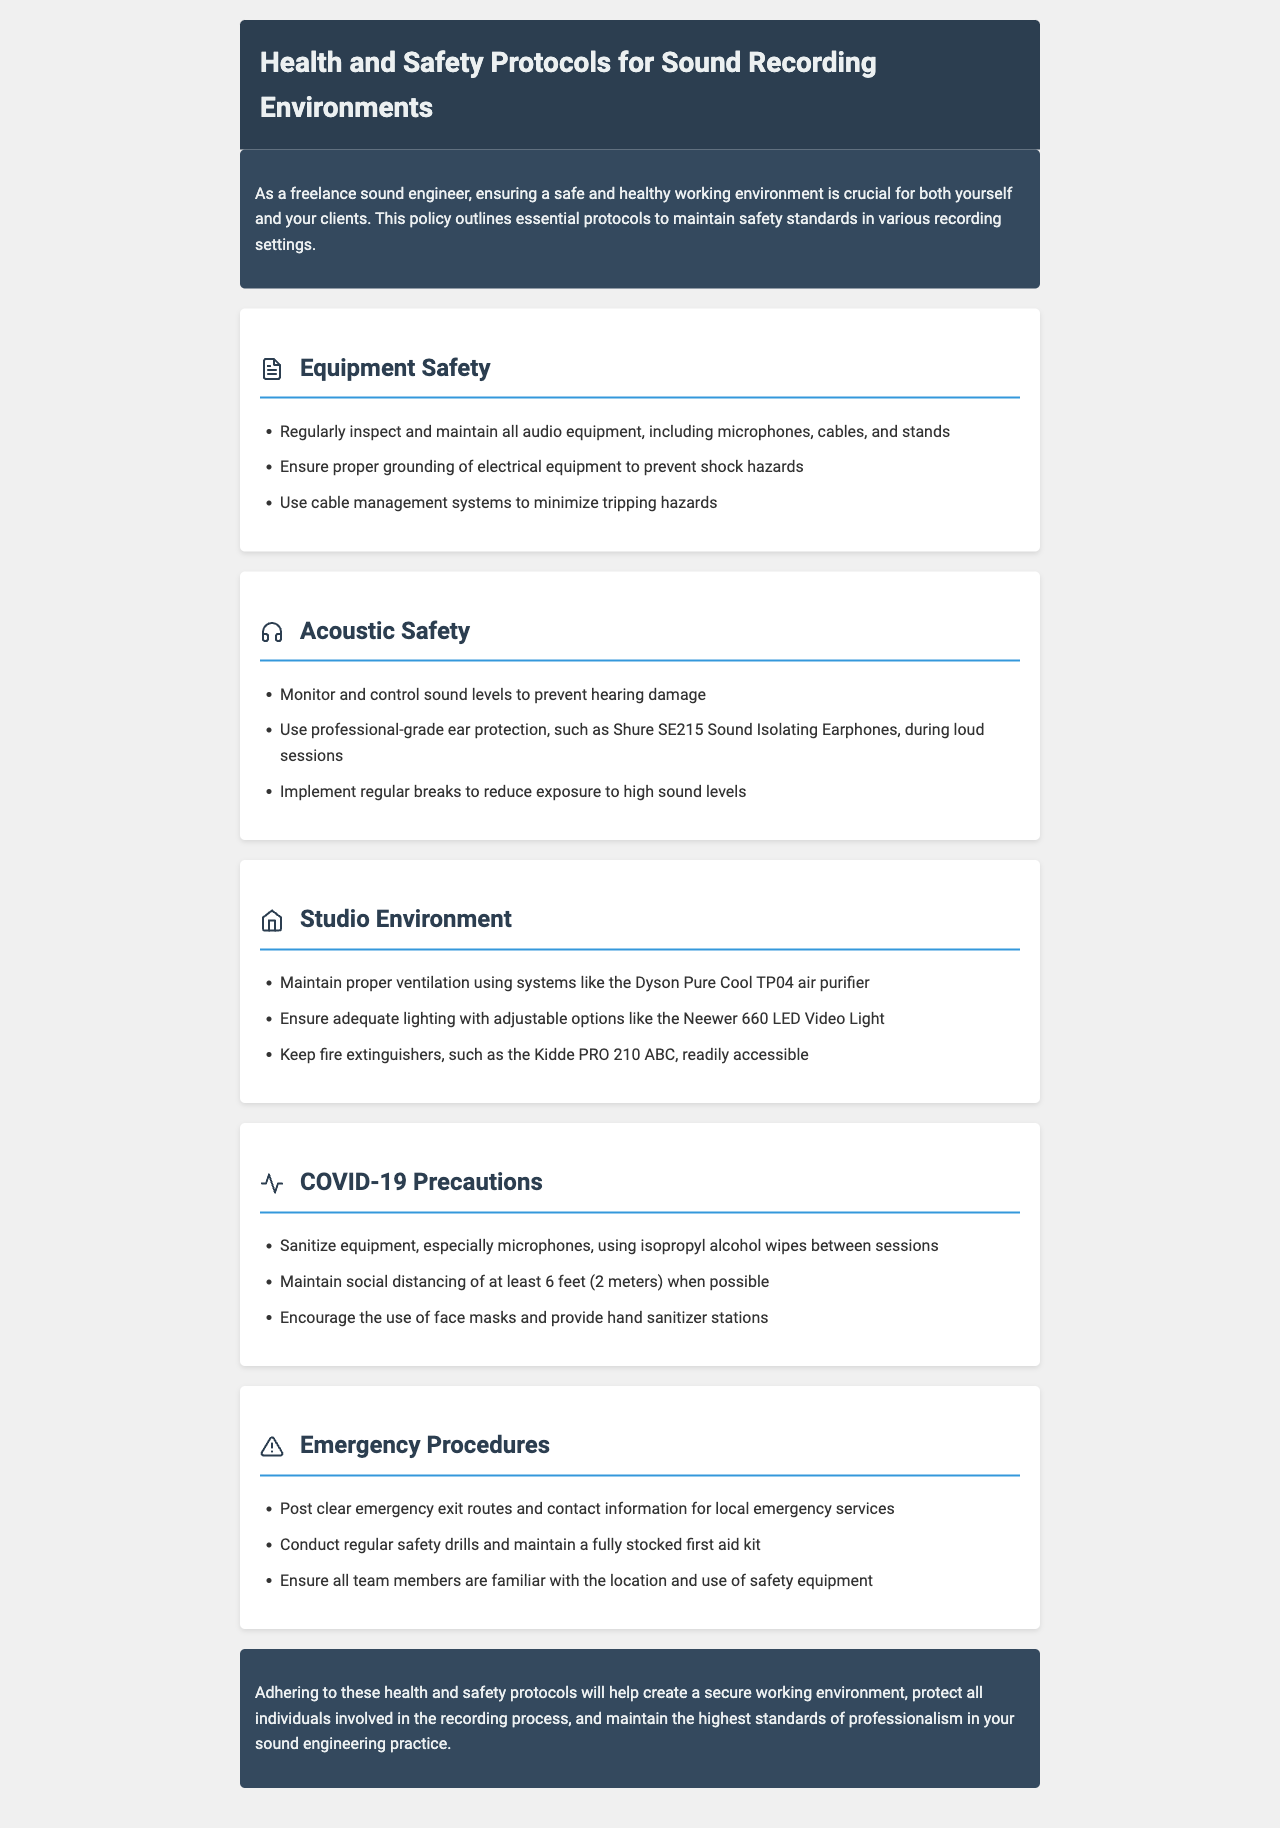What is the title of the document? The title is mentioned in the header section of the document, stating the purpose of the content.
Answer: Health and Safety Protocols for Sound Recording Environments What is the first section of the document? The first section outlines equipment safety, focusing on maintaining audio equipment and preventing hazards.
Answer: Equipment Safety What type of ear protection is recommended? The document specifies a professional-grade ear protection to use during loud sessions, providing specific product details.
Answer: Shure SE215 Sound Isolating Earphones What should be used to ensure adequate lighting? This document suggests specific lighting equipment that should be utilized to maintain a suitable working environment.
Answer: Neewer 660 LED Video Light What is the minimum social distancing recommendation? The policy provides a clear distance guideline that should be followed during recording sessions to ensure safety.
Answer: 6 feet (2 meters) How often should safety drills be conducted? The document explicitly states the frequency of essential safety practices that must be performed in the sound recording environment.
Answer: Regularly What should be used to sanitize equipment? The document suggests a specific cleaning supply that should be employed for sanitizing equipment in between uses.
Answer: Isopropyl alcohol wipes What kind of air purifier is recommended? The document includes a specific product intended for maintaining proper ventilation in sound recording studios.
Answer: Dyson Pure Cool TP04 air purifier How many items are listed under the 'Emergency Procedures' section? The document enumerates the items within the emergency procedures, providing a count of the protocols mentioned.
Answer: Three 